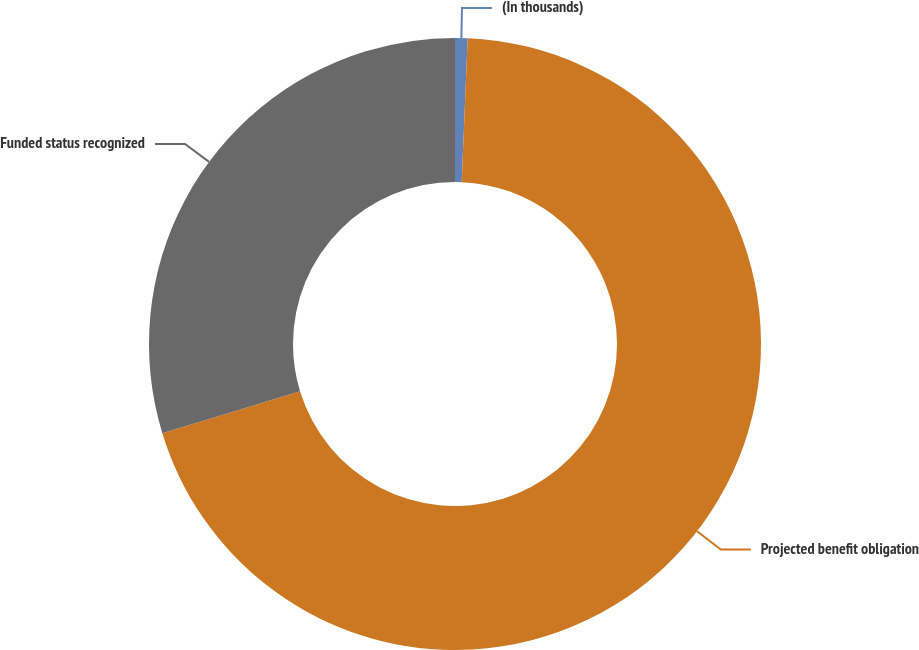Convert chart. <chart><loc_0><loc_0><loc_500><loc_500><pie_chart><fcel>(In thousands)<fcel>Projected benefit obligation<fcel>Funded status recognized<nl><fcel>0.66%<fcel>69.63%<fcel>29.71%<nl></chart> 